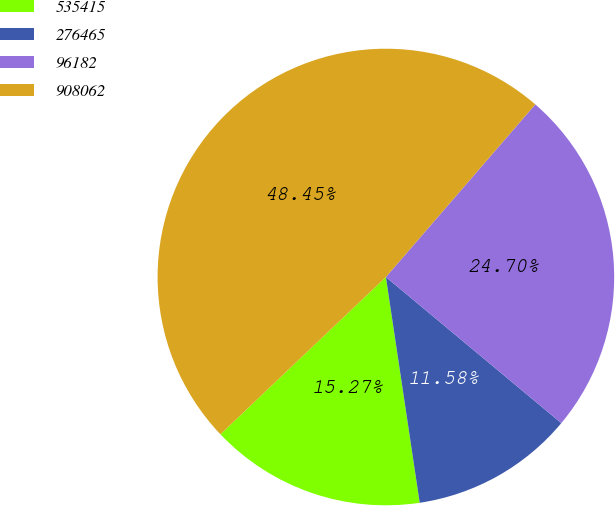<chart> <loc_0><loc_0><loc_500><loc_500><pie_chart><fcel>535415<fcel>276465<fcel>96182<fcel>908062<nl><fcel>15.27%<fcel>11.58%<fcel>24.7%<fcel>48.45%<nl></chart> 